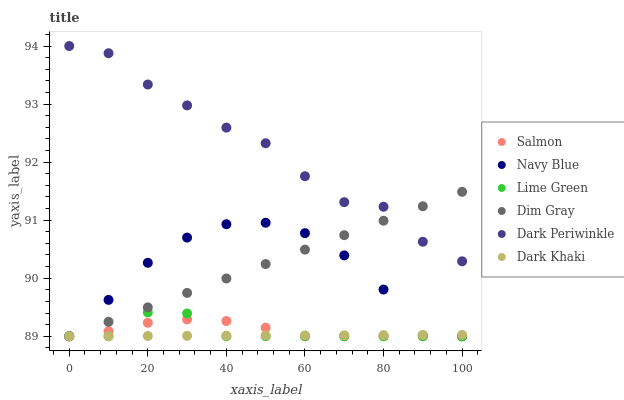Does Dark Khaki have the minimum area under the curve?
Answer yes or no. Yes. Does Dark Periwinkle have the maximum area under the curve?
Answer yes or no. Yes. Does Navy Blue have the minimum area under the curve?
Answer yes or no. No. Does Navy Blue have the maximum area under the curve?
Answer yes or no. No. Is Dark Khaki the smoothest?
Answer yes or no. Yes. Is Dark Periwinkle the roughest?
Answer yes or no. Yes. Is Navy Blue the smoothest?
Answer yes or no. No. Is Navy Blue the roughest?
Answer yes or no. No. Does Dim Gray have the lowest value?
Answer yes or no. Yes. Does Dark Periwinkle have the lowest value?
Answer yes or no. No. Does Dark Periwinkle have the highest value?
Answer yes or no. Yes. Does Navy Blue have the highest value?
Answer yes or no. No. Is Lime Green less than Dark Periwinkle?
Answer yes or no. Yes. Is Dark Periwinkle greater than Navy Blue?
Answer yes or no. Yes. Does Salmon intersect Dark Khaki?
Answer yes or no. Yes. Is Salmon less than Dark Khaki?
Answer yes or no. No. Is Salmon greater than Dark Khaki?
Answer yes or no. No. Does Lime Green intersect Dark Periwinkle?
Answer yes or no. No. 